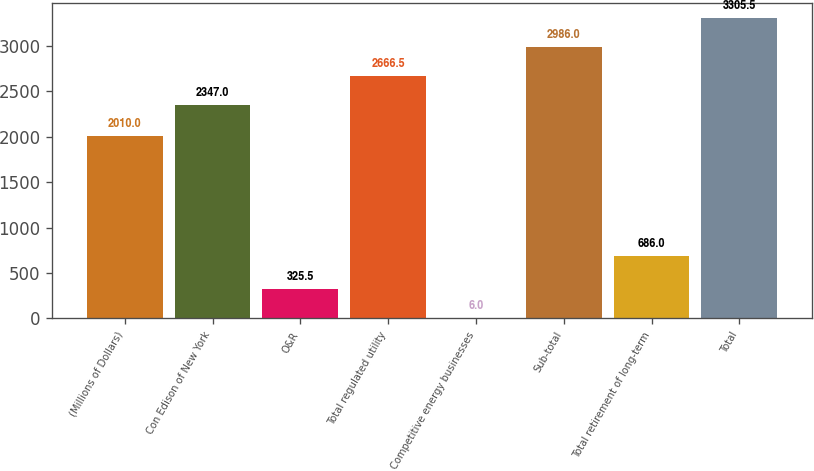<chart> <loc_0><loc_0><loc_500><loc_500><bar_chart><fcel>(Millions of Dollars)<fcel>Con Edison of New York<fcel>O&R<fcel>Total regulated utility<fcel>Competitive energy businesses<fcel>Sub-total<fcel>Total retirement of long-term<fcel>Total<nl><fcel>2010<fcel>2347<fcel>325.5<fcel>2666.5<fcel>6<fcel>2986<fcel>686<fcel>3305.5<nl></chart> 